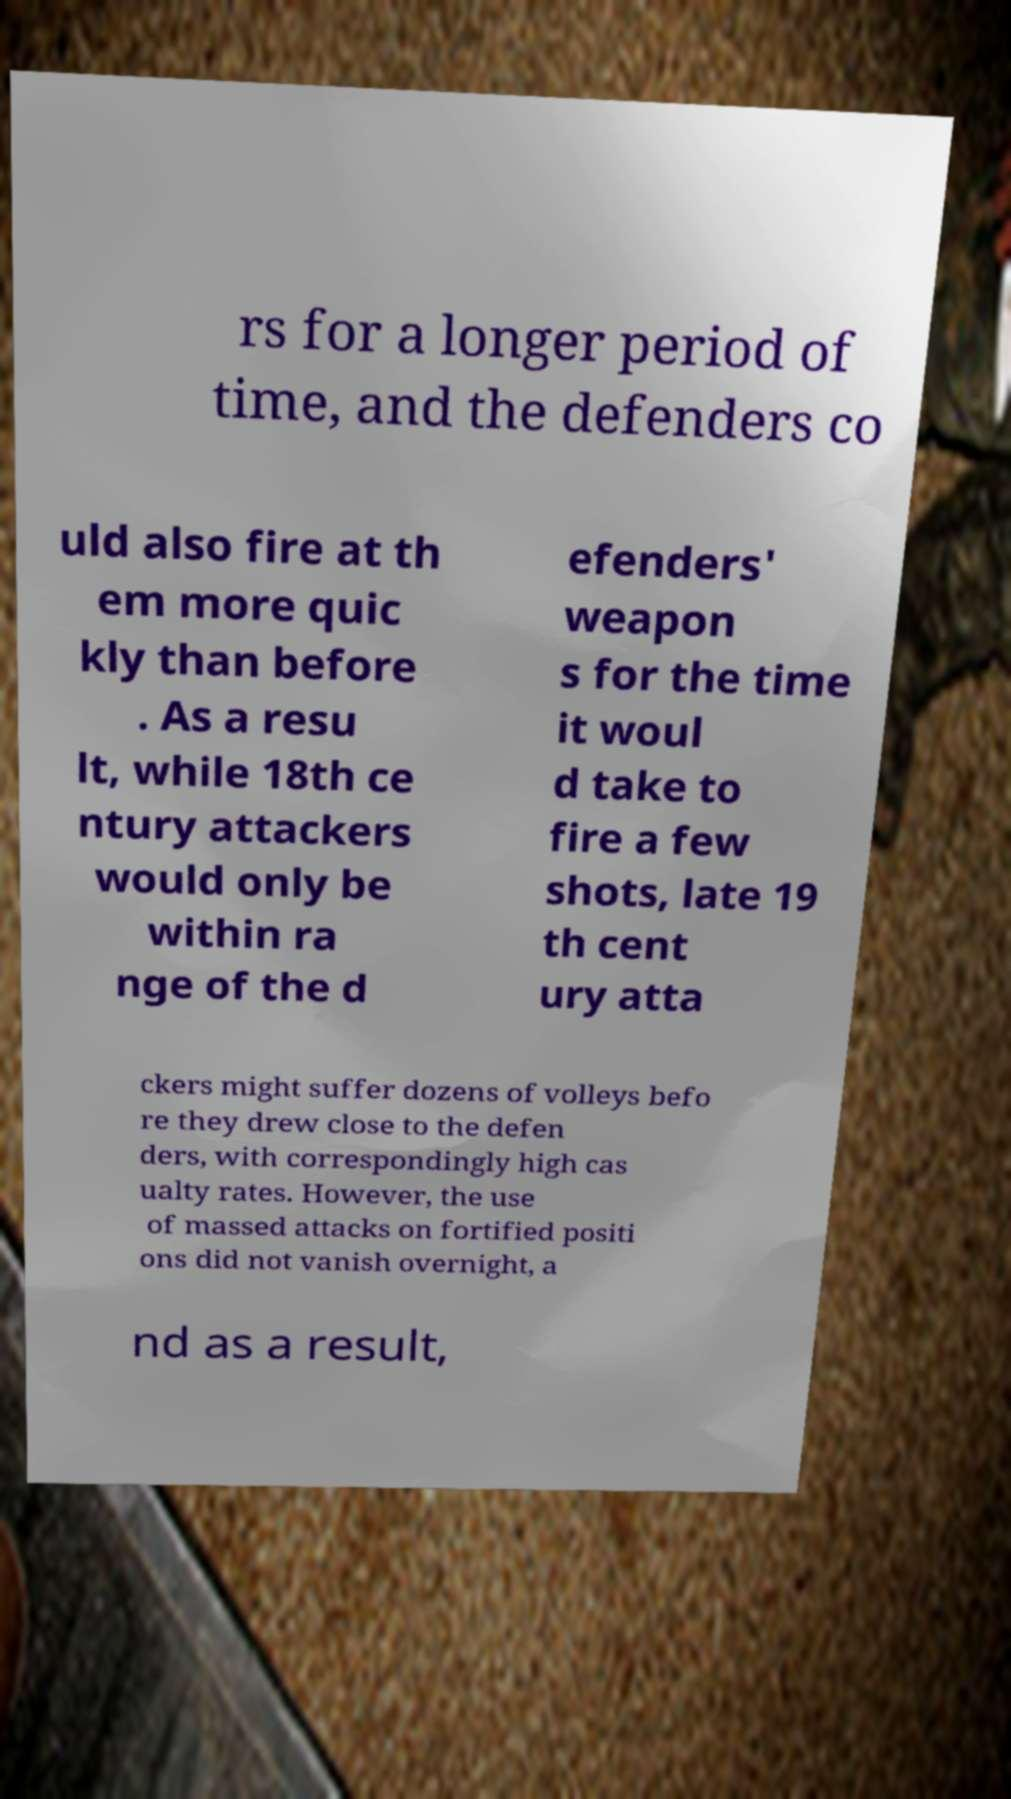What messages or text are displayed in this image? I need them in a readable, typed format. rs for a longer period of time, and the defenders co uld also fire at th em more quic kly than before . As a resu lt, while 18th ce ntury attackers would only be within ra nge of the d efenders' weapon s for the time it woul d take to fire a few shots, late 19 th cent ury atta ckers might suffer dozens of volleys befo re they drew close to the defen ders, with correspondingly high cas ualty rates. However, the use of massed attacks on fortified positi ons did not vanish overnight, a nd as a result, 